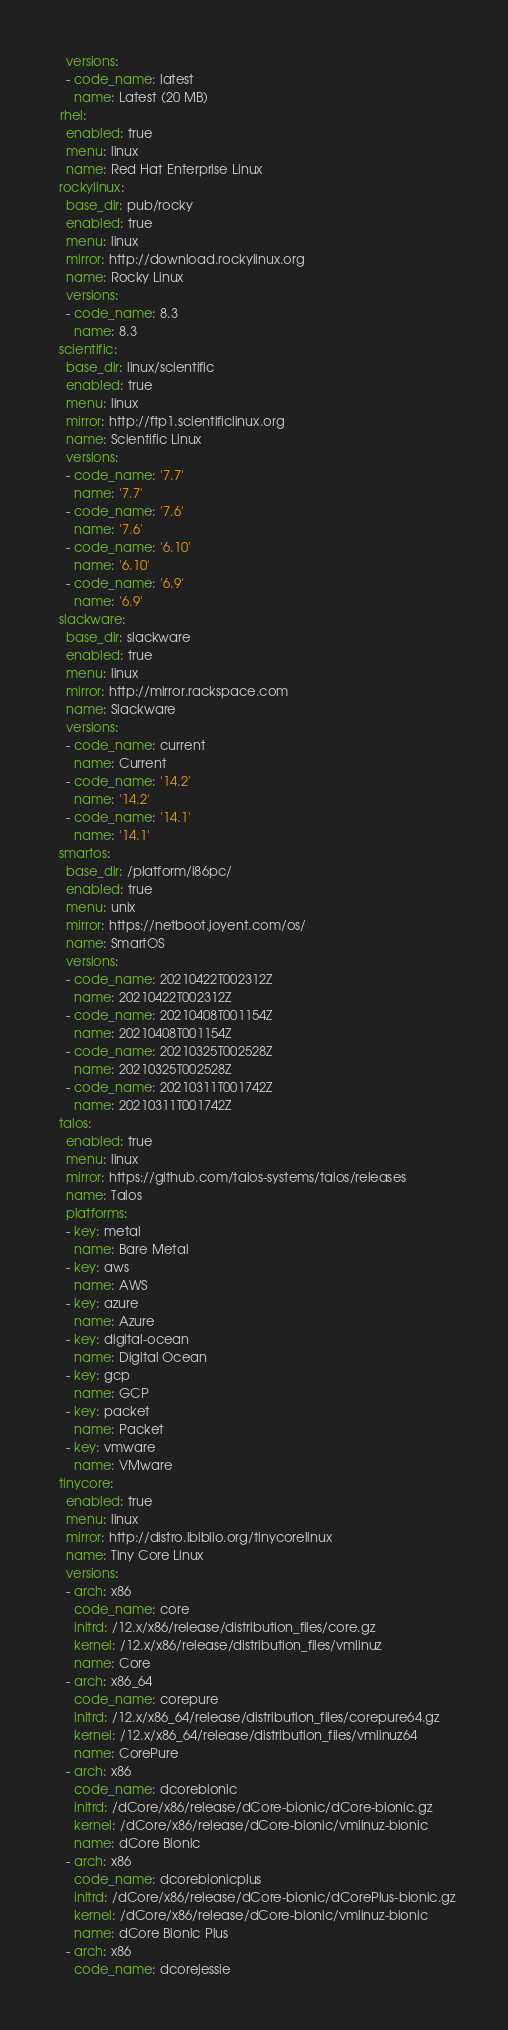<code> <loc_0><loc_0><loc_500><loc_500><_YAML_>    versions:
    - code_name: latest
      name: Latest (20 MB)
  rhel:
    enabled: true
    menu: linux
    name: Red Hat Enterprise Linux
  rockylinux:
    base_dir: pub/rocky
    enabled: true
    menu: linux
    mirror: http://download.rockylinux.org
    name: Rocky Linux
    versions:
    - code_name: 8.3
      name: 8.3
  scientific:
    base_dir: linux/scientific
    enabled: true
    menu: linux
    mirror: http://ftp1.scientificlinux.org
    name: Scientific Linux
    versions:
    - code_name: '7.7'
      name: '7.7'
    - code_name: '7.6'
      name: '7.6'
    - code_name: '6.10'
      name: '6.10'
    - code_name: '6.9'
      name: '6.9'
  slackware:
    base_dir: slackware
    enabled: true
    menu: linux
    mirror: http://mirror.rackspace.com
    name: Slackware
    versions:
    - code_name: current
      name: Current
    - code_name: '14.2'
      name: '14.2'
    - code_name: '14.1'
      name: '14.1'
  smartos:
    base_dir: /platform/i86pc/
    enabled: true
    menu: unix
    mirror: https://netboot.joyent.com/os/
    name: SmartOS
    versions:
    - code_name: 20210422T002312Z
      name: 20210422T002312Z
    - code_name: 20210408T001154Z
      name: 20210408T001154Z
    - code_name: 20210325T002528Z
      name: 20210325T002528Z
    - code_name: 20210311T001742Z
      name: 20210311T001742Z
  talos:
    enabled: true
    menu: linux
    mirror: https://github.com/talos-systems/talos/releases
    name: Talos
    platforms:
    - key: metal
      name: Bare Metal
    - key: aws
      name: AWS
    - key: azure
      name: Azure
    - key: digital-ocean
      name: Digital Ocean
    - key: gcp
      name: GCP
    - key: packet
      name: Packet
    - key: vmware
      name: VMware
  tinycore:
    enabled: true
    menu: linux
    mirror: http://distro.ibiblio.org/tinycorelinux
    name: Tiny Core Linux
    versions:
    - arch: x86
      code_name: core
      initrd: /12.x/x86/release/distribution_files/core.gz
      kernel: /12.x/x86/release/distribution_files/vmlinuz
      name: Core
    - arch: x86_64
      code_name: corepure
      initrd: /12.x/x86_64/release/distribution_files/corepure64.gz
      kernel: /12.x/x86_64/release/distribution_files/vmlinuz64
      name: CorePure
    - arch: x86
      code_name: dcorebionic
      initrd: /dCore/x86/release/dCore-bionic/dCore-bionic.gz
      kernel: /dCore/x86/release/dCore-bionic/vmlinuz-bionic
      name: dCore Bionic
    - arch: x86
      code_name: dcorebionicplus
      initrd: /dCore/x86/release/dCore-bionic/dCorePlus-bionic.gz
      kernel: /dCore/x86/release/dCore-bionic/vmlinuz-bionic
      name: dCore Bionic Plus
    - arch: x86
      code_name: dcorejessie</code> 